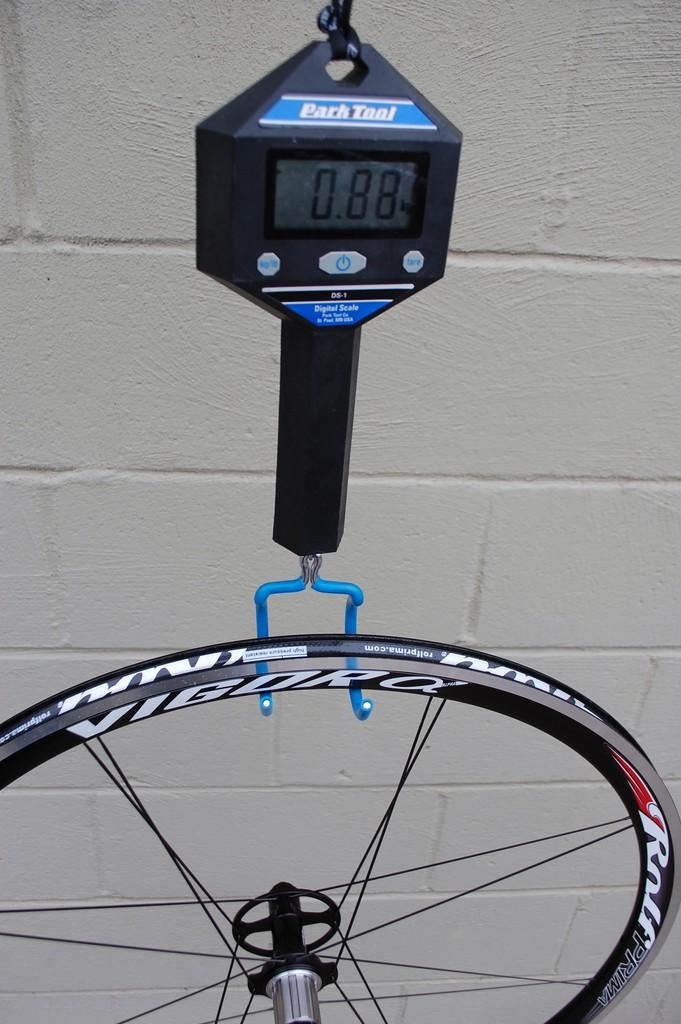What is the main object in the image? There is a weighing machine in the image. What is attached to the weighing machine? A wheel is hanging from the weighing machine. What can be seen in the background of the image? There is a wall in the background of the image. How does the weighing machine attack the wall in the image? The weighing machine does not attack the wall in the image; it is a stationary object, and there is no indication of any aggressive behavior. 